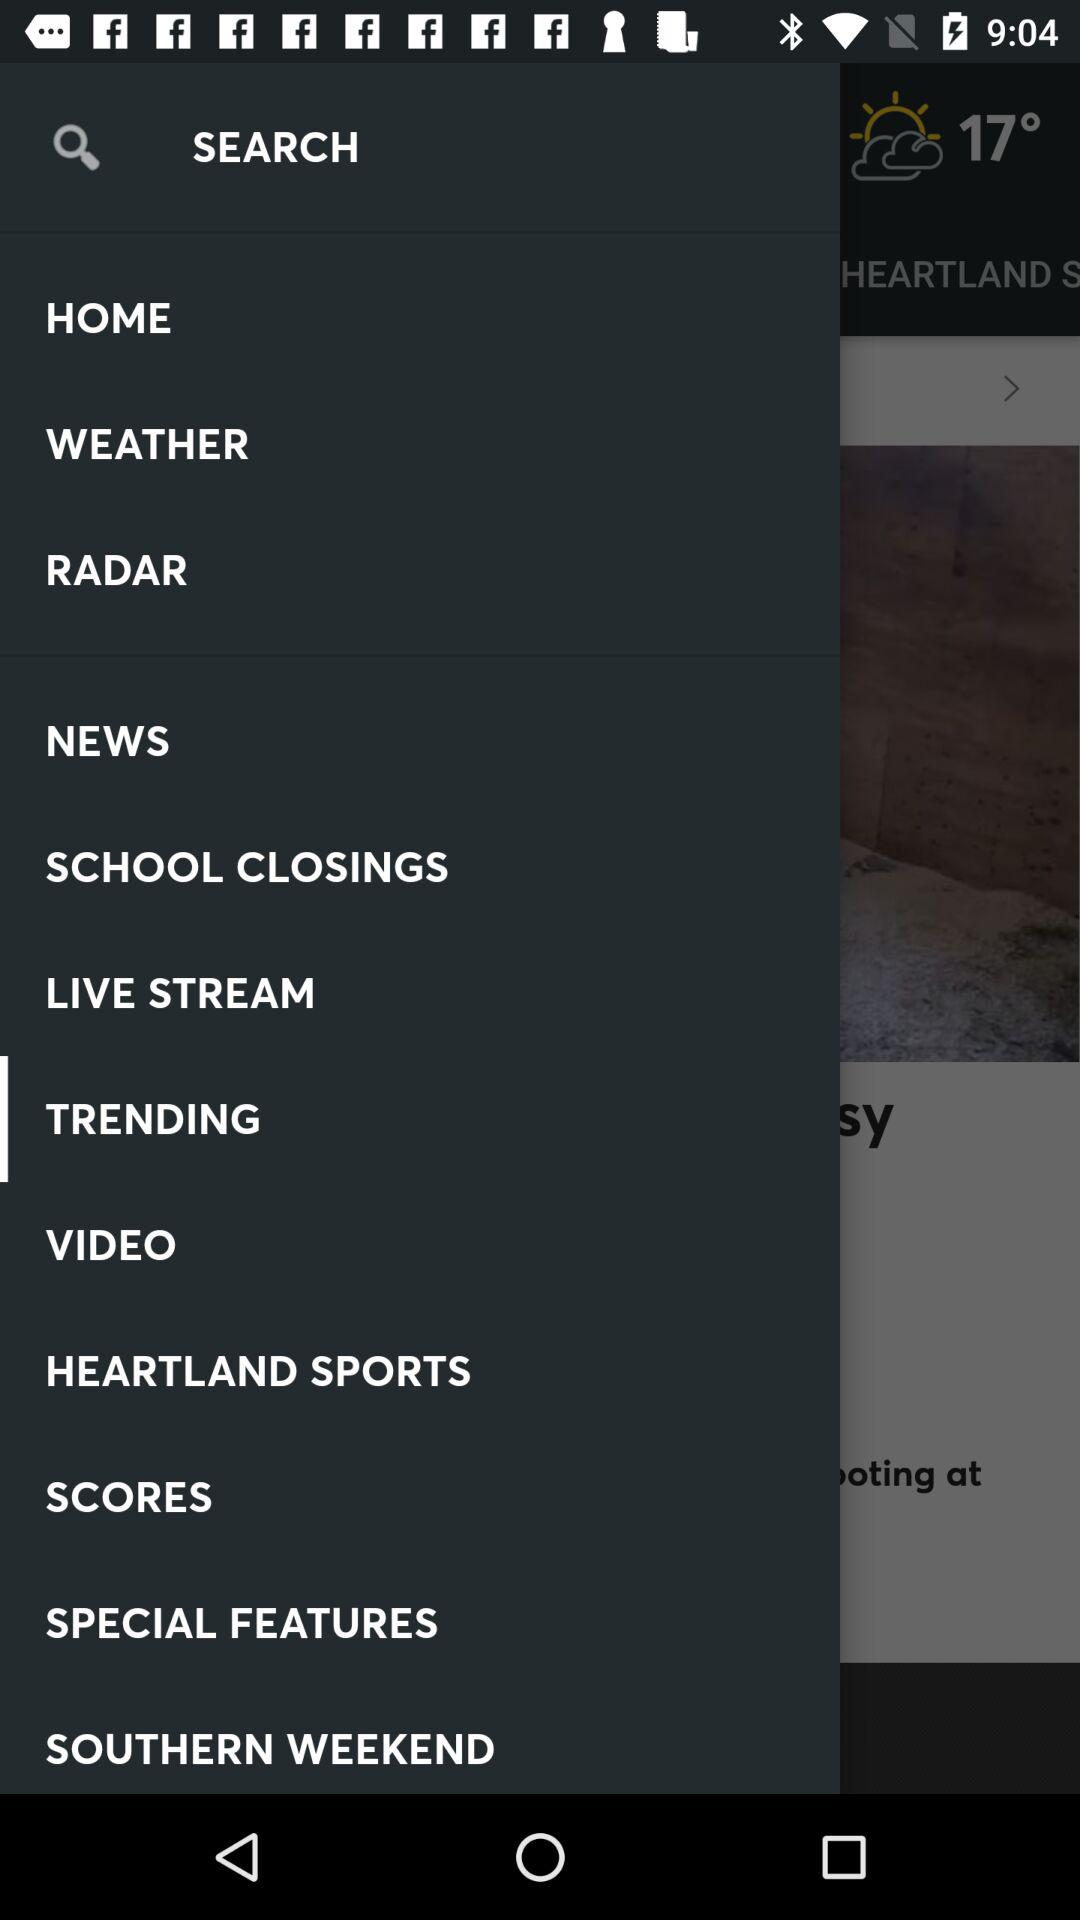What is the given temperature? The given temperature is 17°. 